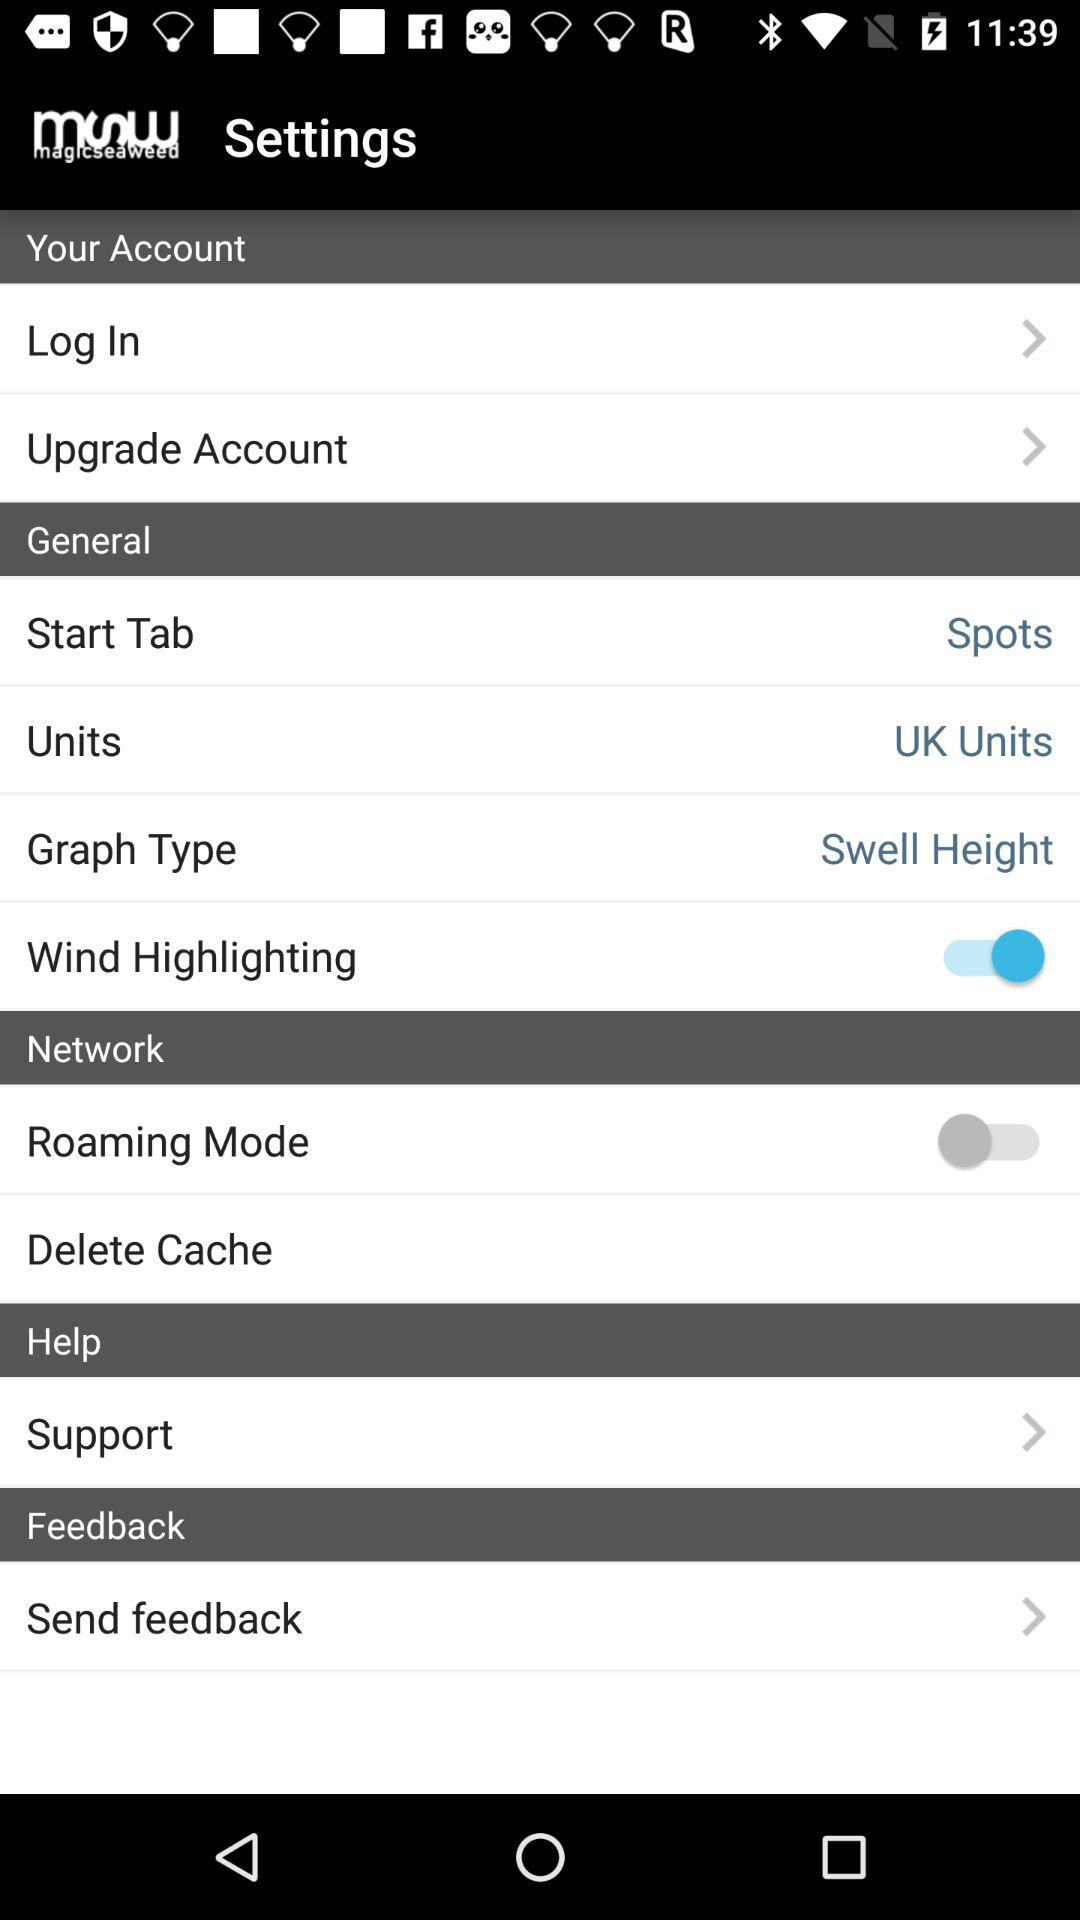What is the status of the "Roaming Mode"? The status is "off". 